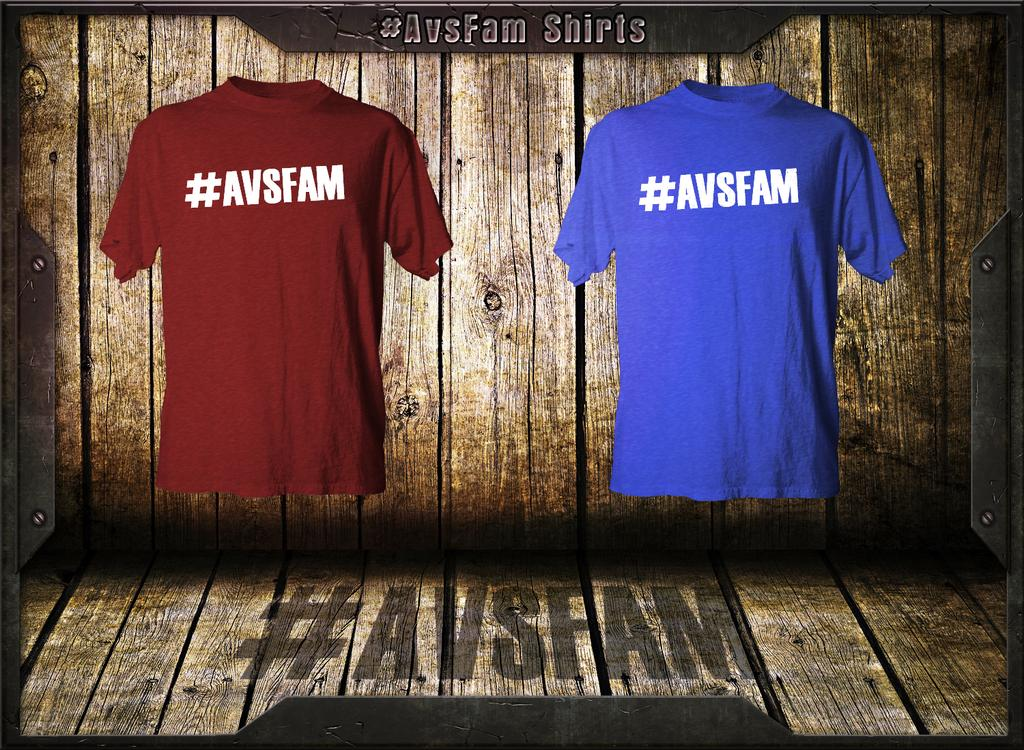<image>
Give a short and clear explanation of the subsequent image. the word avsfam that is on a blue shirt 